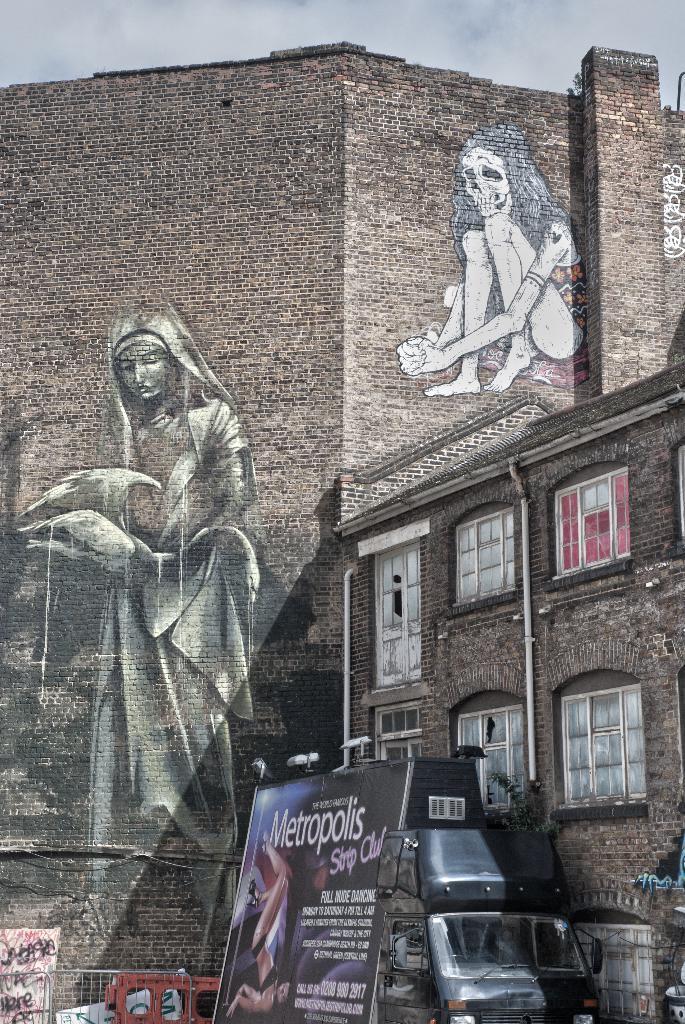In one or two sentences, can you explain what this image depicts? In this image the sky truncated towards the top of the image, there are buildings, there is a building truncated towards the right of the image, there are windows, there is a painting on the wall, there is a fencing truncated towards the bottom of the image, there is a vehicle truncated towards the bottom of the image, there is a board truncated towards the bottom of the image, there is text on the board. 